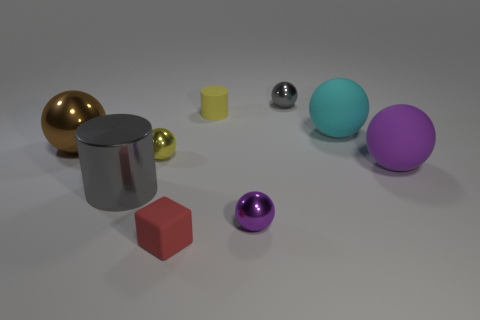There is a gray object that is in front of the gray shiny sphere; what is it made of?
Offer a very short reply. Metal. What is the size of the purple rubber object?
Keep it short and to the point. Large. Is the tiny ball in front of the large purple thing made of the same material as the brown sphere?
Your answer should be very brief. Yes. How many metal spheres are there?
Give a very brief answer. 4. How many objects are large balls or small cyan balls?
Offer a terse response. 3. What number of small cylinders are behind the cylinder behind the big matte thing in front of the big brown thing?
Make the answer very short. 0. Are there any other things that have the same color as the rubber cylinder?
Your answer should be very brief. Yes. There is a shiny ball in front of the large purple matte sphere; is its color the same as the large sphere that is on the right side of the cyan rubber object?
Provide a succinct answer. Yes. Are there more purple shiny objects behind the tiny yellow ball than small gray objects that are on the right side of the gray shiny ball?
Your answer should be very brief. No. What is the material of the small purple ball?
Your answer should be compact. Metal. 